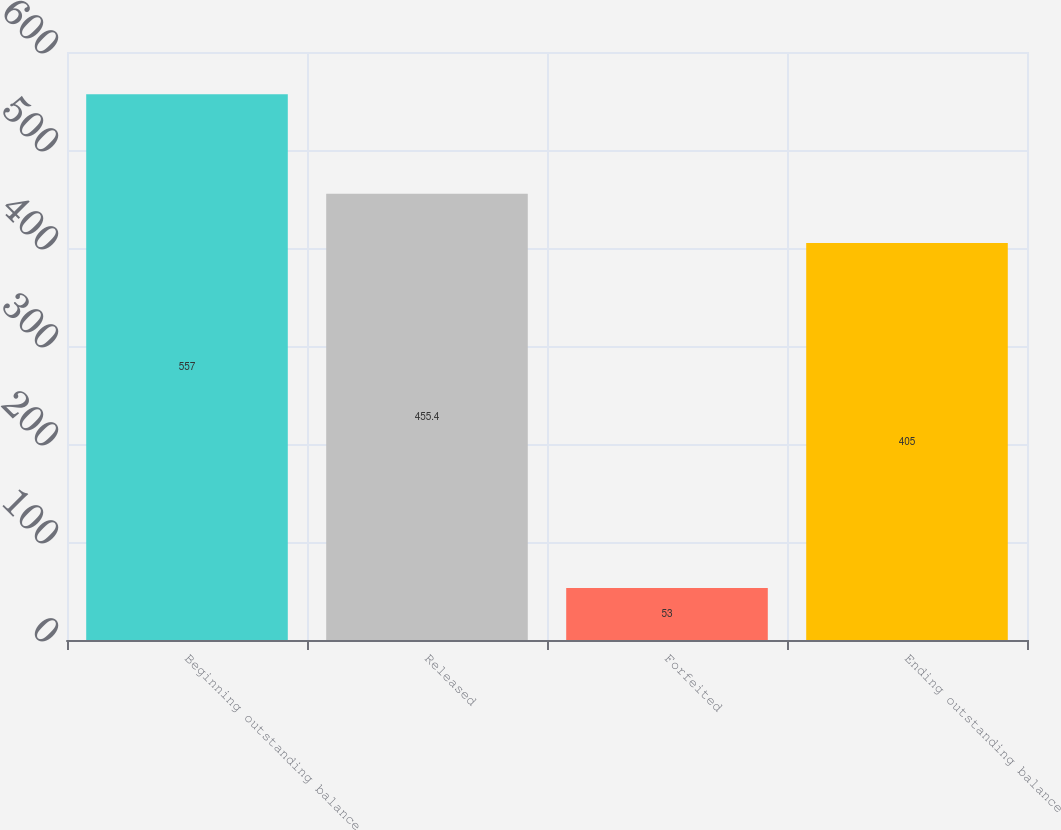Convert chart. <chart><loc_0><loc_0><loc_500><loc_500><bar_chart><fcel>Beginning outstanding balance<fcel>Released<fcel>Forfeited<fcel>Ending outstanding balance<nl><fcel>557<fcel>455.4<fcel>53<fcel>405<nl></chart> 